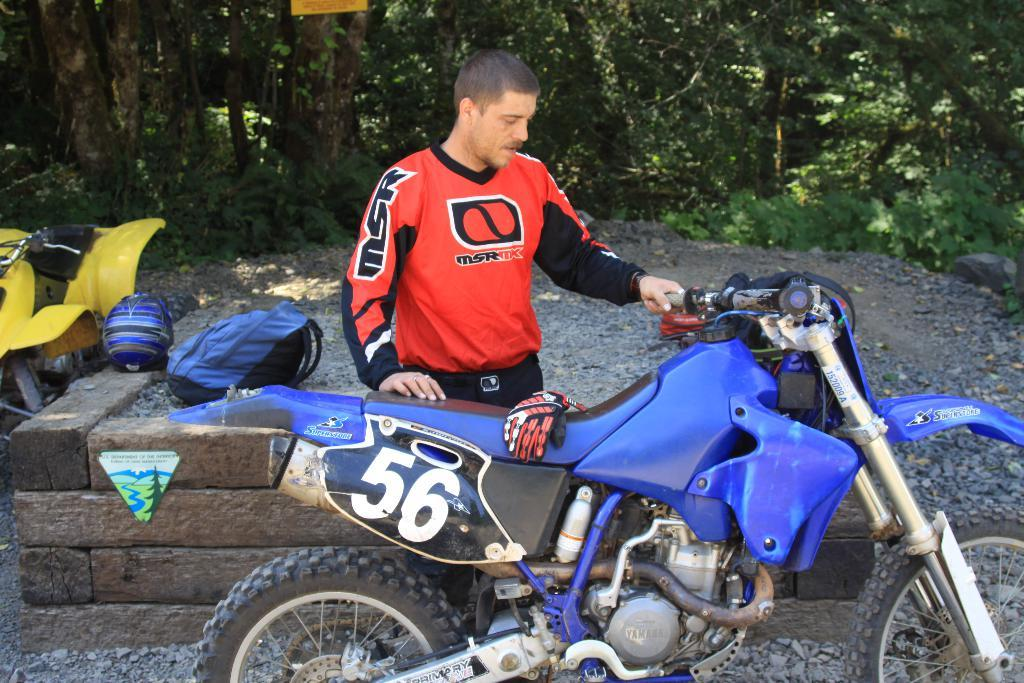Who is present in the image? There is a man in the image. What object can be seen near the man? There is a bag in the image. What protective gear is visible in the image? There is a helmet in the image. What type of objects are made of wood in the image? There are wooden objects in the image. What mode of transportation is present in the image? There are bikes in the image. What can be found on the ground in the image? There are stones on the ground in the image. What is placed on one of the bikes in the image? There is a glove on a bike in the image. What can be seen in the distance in the image? There are trees in the background of the image. What type of calendar is hanging on the tree in the image? There is no calendar present in the image; it features a man, a bag, a helmet, wooden objects, bikes, stones, a glove, and trees. What part of the man's body is shown interacting with the ear in the image? There is no ear present in the image. What type of hydrant can be seen near the bikes in the image? There is no hydrant present in the image; it features a man, a bag, a helmet, wooden objects, bikes, stones, a glove, and trees. 